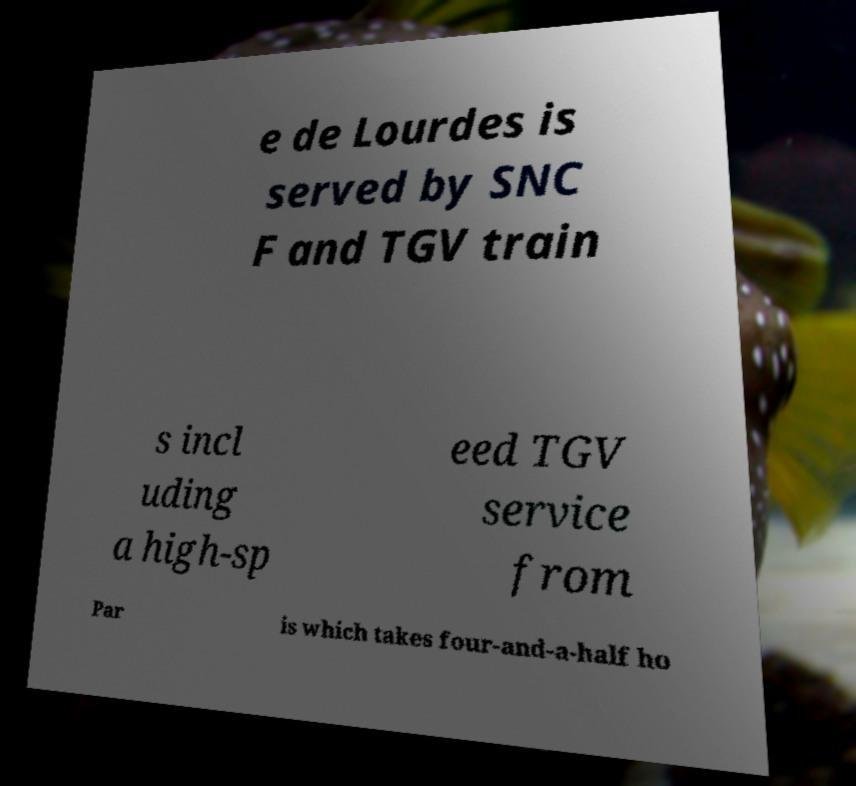Could you assist in decoding the text presented in this image and type it out clearly? e de Lourdes is served by SNC F and TGV train s incl uding a high-sp eed TGV service from Par is which takes four-and-a-half ho 